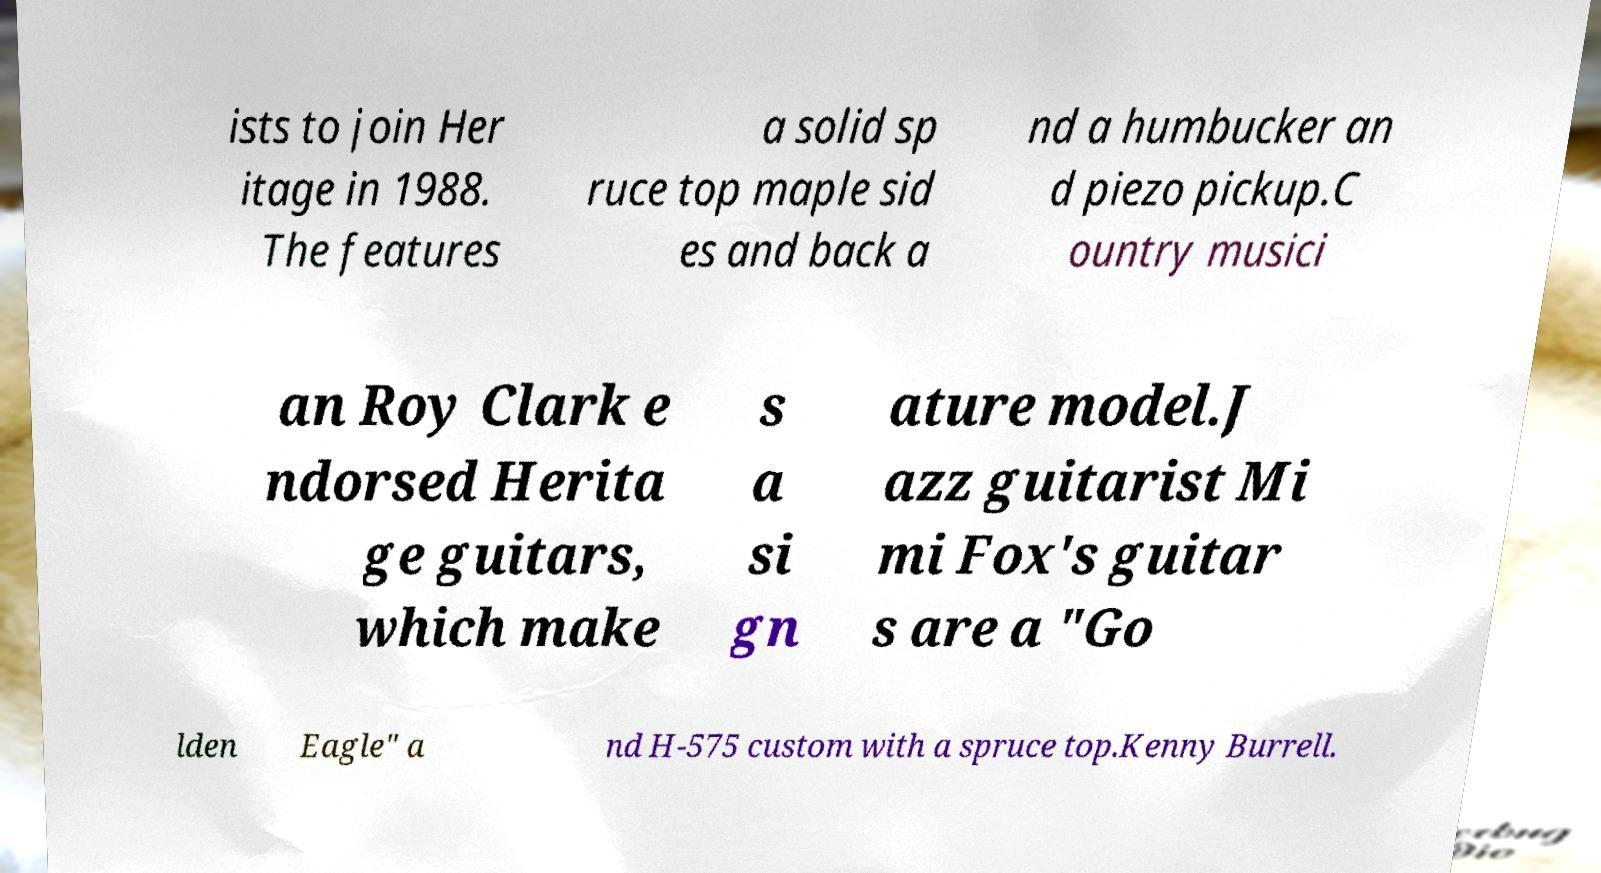Can you read and provide the text displayed in the image?This photo seems to have some interesting text. Can you extract and type it out for me? ists to join Her itage in 1988. The features a solid sp ruce top maple sid es and back a nd a humbucker an d piezo pickup.C ountry musici an Roy Clark e ndorsed Herita ge guitars, which make s a si gn ature model.J azz guitarist Mi mi Fox's guitar s are a "Go lden Eagle" a nd H-575 custom with a spruce top.Kenny Burrell. 